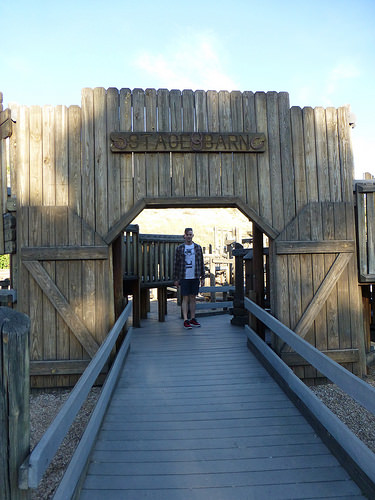<image>
Can you confirm if the man is on the boardwalk? Yes. Looking at the image, I can see the man is positioned on top of the boardwalk, with the boardwalk providing support. 